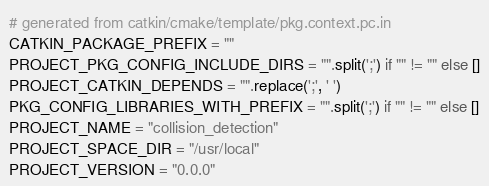<code> <loc_0><loc_0><loc_500><loc_500><_Python_># generated from catkin/cmake/template/pkg.context.pc.in
CATKIN_PACKAGE_PREFIX = ""
PROJECT_PKG_CONFIG_INCLUDE_DIRS = "".split(';') if "" != "" else []
PROJECT_CATKIN_DEPENDS = "".replace(';', ' ')
PKG_CONFIG_LIBRARIES_WITH_PREFIX = "".split(';') if "" != "" else []
PROJECT_NAME = "collision_detection"
PROJECT_SPACE_DIR = "/usr/local"
PROJECT_VERSION = "0.0.0"
</code> 